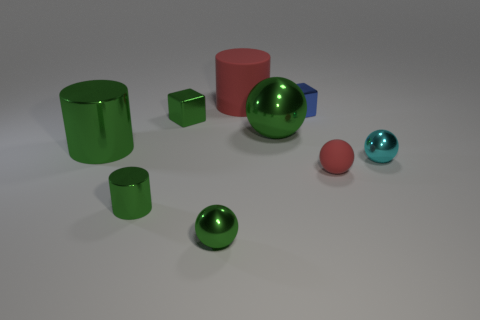Subtract all tiny green metallic spheres. How many spheres are left? 3 Subtract 1 spheres. How many spheres are left? 3 Subtract all blue cubes. How many cubes are left? 1 Add 1 small green metallic cylinders. How many objects exist? 10 Subtract all cylinders. How many objects are left? 6 Subtract all yellow cylinders. How many blue blocks are left? 1 Add 2 tiny shiny objects. How many tiny shiny objects exist? 7 Subtract 0 brown cylinders. How many objects are left? 9 Subtract all red cubes. Subtract all gray cylinders. How many cubes are left? 2 Subtract all purple cylinders. Subtract all large red matte objects. How many objects are left? 8 